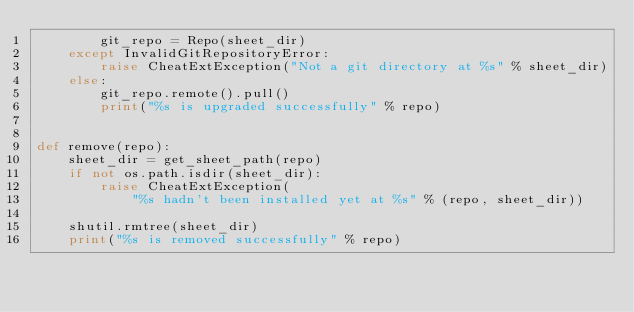Convert code to text. <code><loc_0><loc_0><loc_500><loc_500><_Python_>        git_repo = Repo(sheet_dir)
    except InvalidGitRepositoryError:
        raise CheatExtException("Not a git directory at %s" % sheet_dir)
    else:
        git_repo.remote().pull()
        print("%s is upgraded successfully" % repo)


def remove(repo):
    sheet_dir = get_sheet_path(repo)
    if not os.path.isdir(sheet_dir):
        raise CheatExtException(
            "%s hadn't been installed yet at %s" % (repo, sheet_dir))

    shutil.rmtree(sheet_dir)
    print("%s is removed successfully" % repo)
</code> 